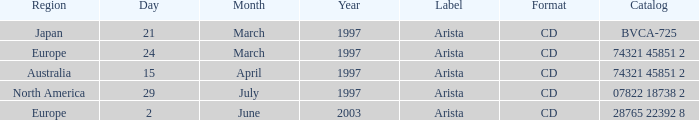Write the full table. {'header': ['Region', 'Day', 'Month', 'Year', 'Label', 'Format', 'Catalog'], 'rows': [['Japan', '21', 'March', '1997', 'Arista', 'CD', 'BVCA-725'], ['Europe', '24', 'March', '1997', 'Arista', 'CD', '74321 45851 2'], ['Australia', '15', 'April', '1997', 'Arista', 'CD', '74321 45851 2'], ['North America', '29', 'July', '1997', 'Arista', 'CD', '07822 18738 2'], ['Europe', '2', 'June', '2003', 'Arista', 'CD', '28765 22392 8']]} What Format has the Region of Europe and a Catalog of 74321 45851 2? CD. 